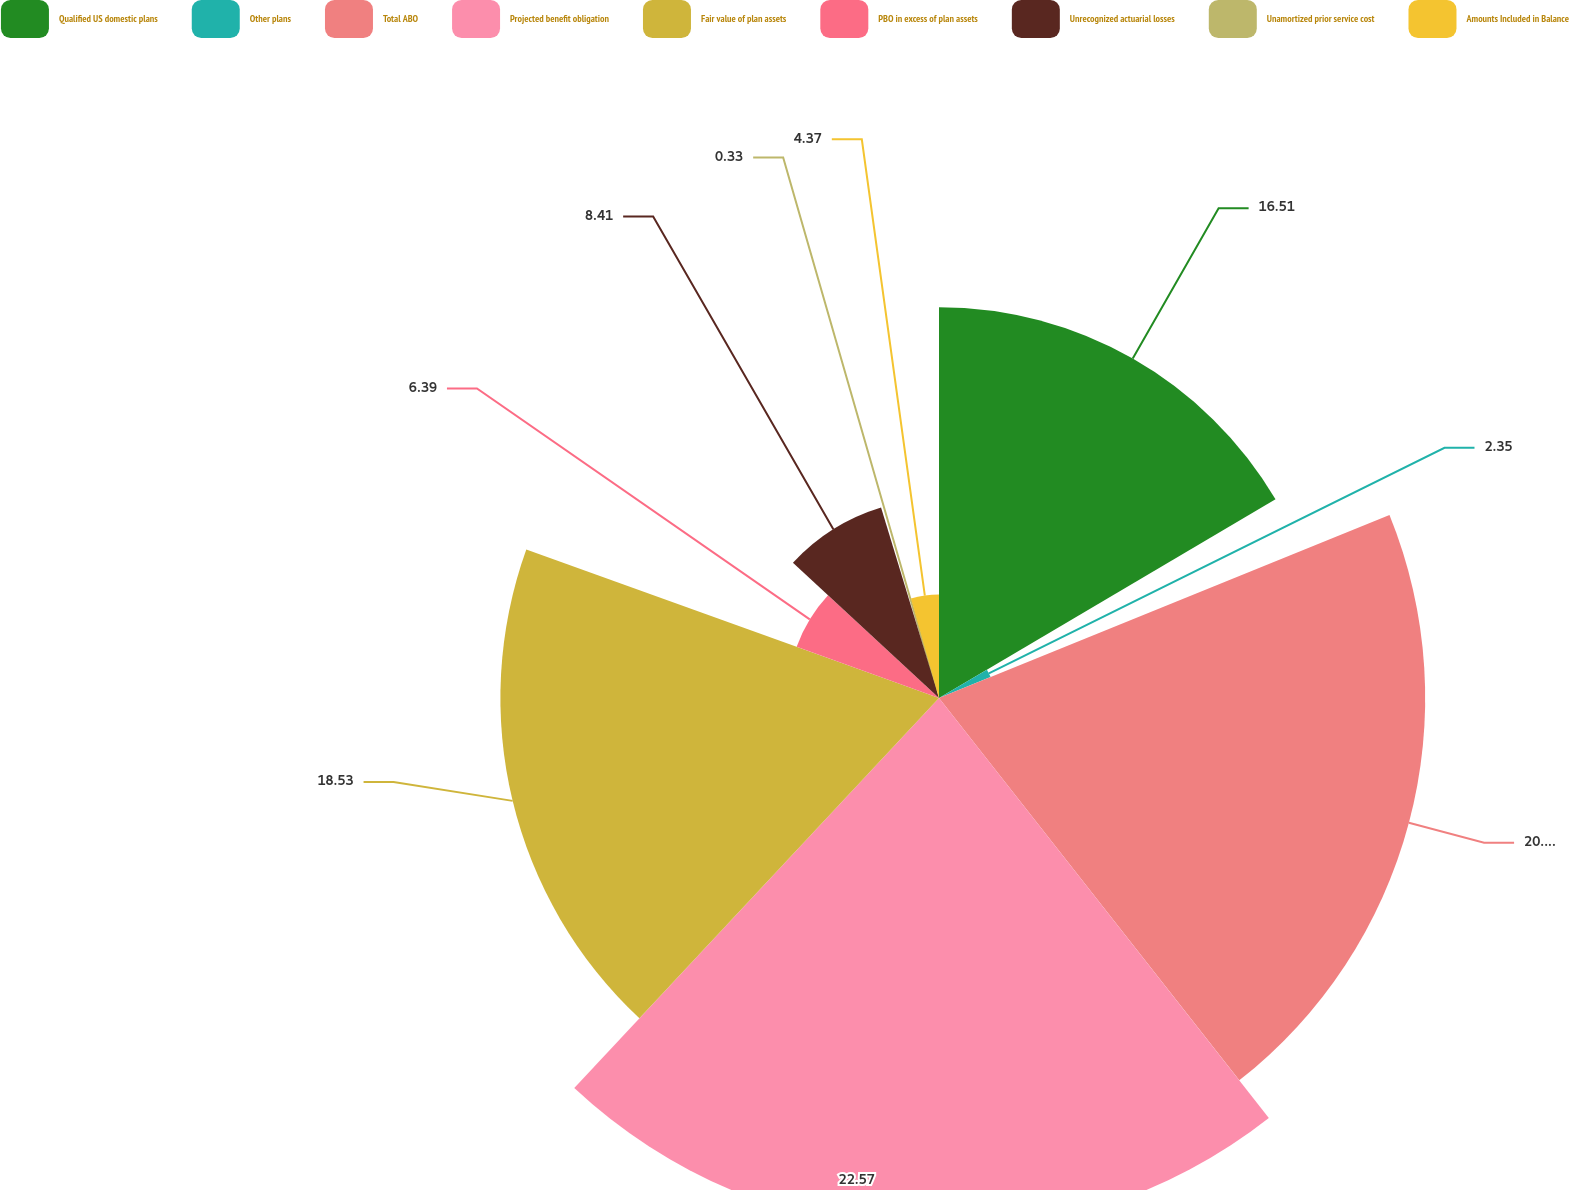Convert chart to OTSL. <chart><loc_0><loc_0><loc_500><loc_500><pie_chart><fcel>Qualified US domestic plans<fcel>Other plans<fcel>Total ABO<fcel>Projected benefit obligation<fcel>Fair value of plan assets<fcel>PBO in excess of plan assets<fcel>Unrecognized actuarial losses<fcel>Unamortized prior service cost<fcel>Amounts Included in Balance<nl><fcel>16.51%<fcel>2.35%<fcel>20.54%<fcel>22.56%<fcel>18.53%<fcel>6.39%<fcel>8.41%<fcel>0.33%<fcel>4.37%<nl></chart> 